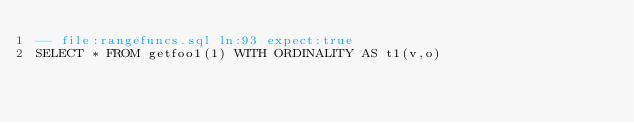<code> <loc_0><loc_0><loc_500><loc_500><_SQL_>-- file:rangefuncs.sql ln:93 expect:true
SELECT * FROM getfoo1(1) WITH ORDINALITY AS t1(v,o)
</code> 